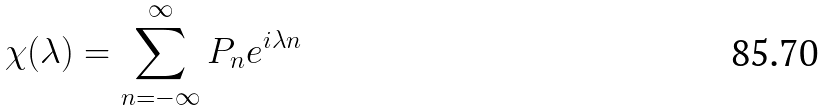Convert formula to latex. <formula><loc_0><loc_0><loc_500><loc_500>\chi ( \lambda ) = \sum _ { n = - \infty } ^ { \infty } P _ { n } e ^ { i \lambda n }</formula> 